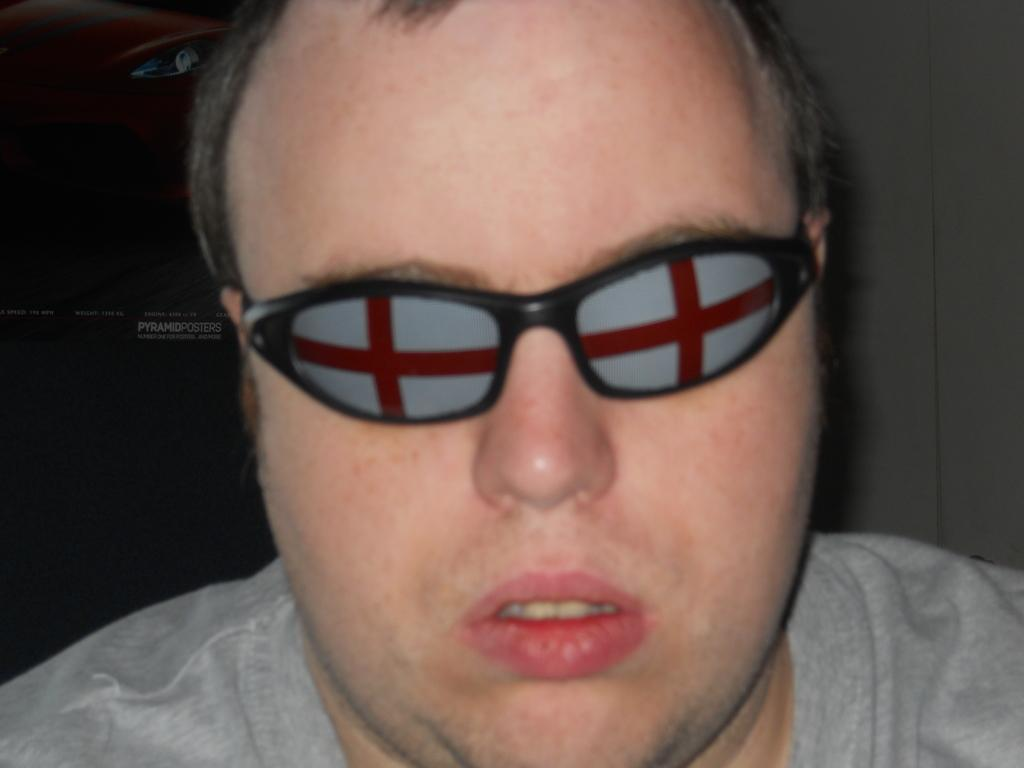Who is the main subject in the image? There is a man in the image. What is the man wearing in the image? The man is wearing glasses in the image. Where is the man positioned in the image? The man is in the center of the image. How many legs does the record have in the image? There is no record present in the image, so it is not possible to determine how many legs it might have. 